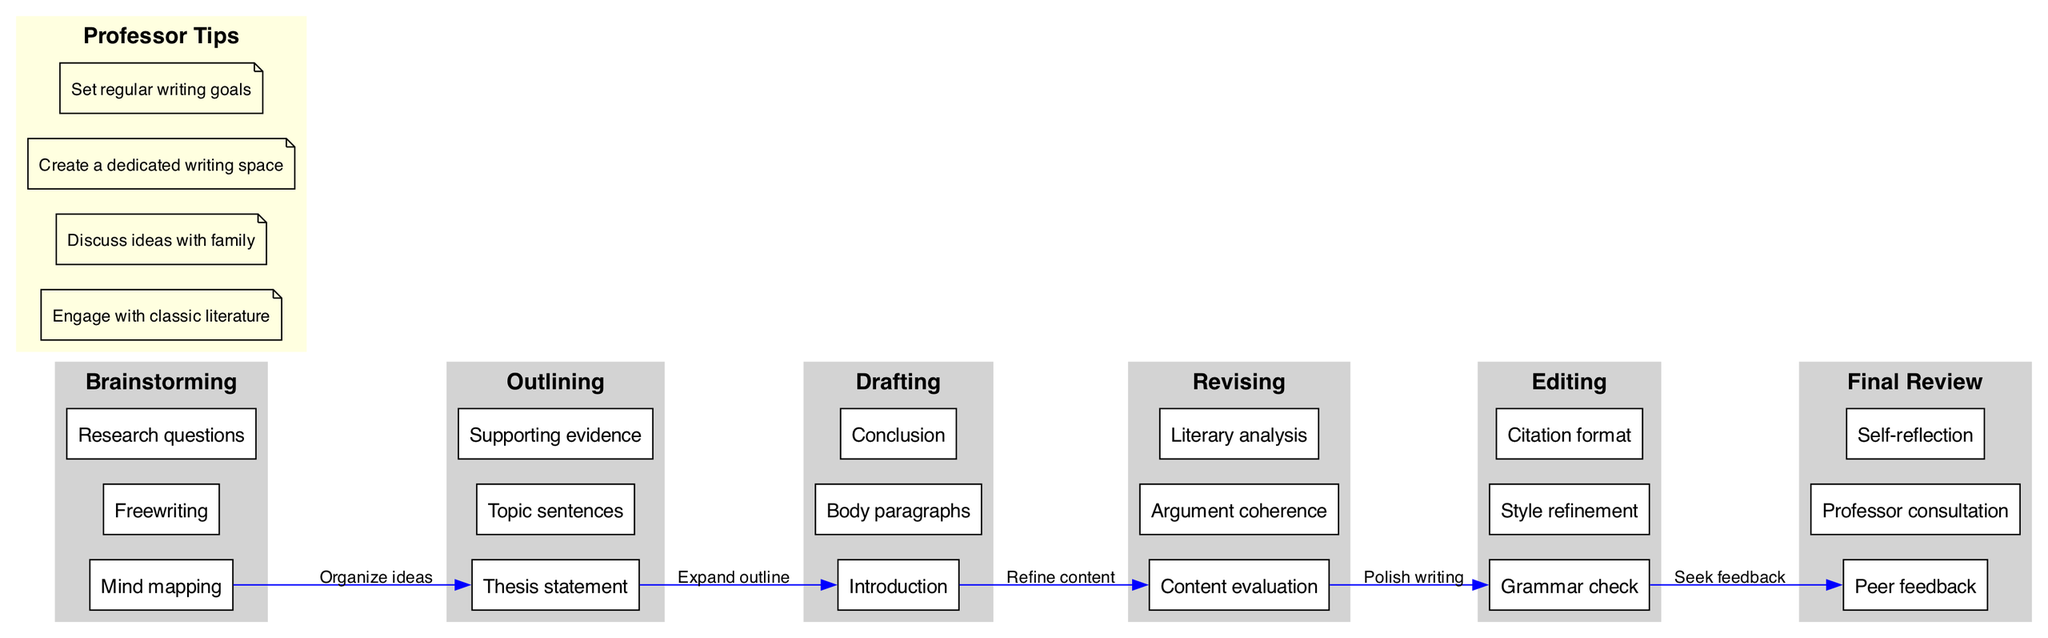What are the main stages of the writing process? The main stages outlined in the diagram are Brainstorming, Outlining, Drafting, Revising, Editing, and Final Review. This information is directly gathered from the "main_stages" section in the diagram.
Answer: Brainstorming, Outlining, Drafting, Revising, Editing, Final Review How many sub-elements are there under 'Drafting'? In the diagram, 'Drafting' has three sub-elements: Introduction, Body paragraphs, and Conclusion. This is found by counting the items listed under the 'Drafting' section of the "sub_elements" in the diagram.
Answer: 3 Which stage comes immediately after 'Outlining'? According to the diagram, 'Drafting' is the stage that immediately follows 'Outlining'. This relationship is indicated by the connection between those two stages, as illustrated by the flow arrows.
Answer: Drafting What is the purpose of 'Revising'? The purpose of 'Revising' includes content evaluation, argument coherence, and literary analysis. This is determined by examining the sub-elements listed under 'Revising' in the diagram.
Answer: Content evaluation, argument coherence, literary analysis What feedback mechanisms are included in the 'Final Review'? The feedback mechanisms for 'Final Review' include peer feedback, professor consultation, and self-reflection. This information is gathered from the sub-elements associated with the 'Final Review' stage.
Answer: Peer feedback, professor consultation, self-reflection How many connections are there between the stages in the diagram? The diagram shows a total of five connections between stages, linking everything from Brainstorming to Final Review. This can be confirmed by counting the entries listed in the "connections" section of the diagram.
Answer: 5 Name a professor tip related to the writing process. One of the professor tips listed in the diagram is to engage with classic literature. This comes directly from the tips provided in the "professor_tips" section of the diagram.
Answer: Engage with classic literature What is the label for the connection from 'Revising' to 'Editing'? The label for this connection is "Polish writing," which appears in the connections list and serves to describe the action to be taken between these two stages.
Answer: Polish writing 